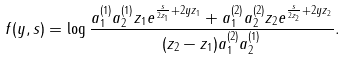<formula> <loc_0><loc_0><loc_500><loc_500>f ( y , s ) = \log \frac { a _ { 1 } ^ { ( 1 ) } a _ { 2 } ^ { ( 1 ) } z _ { 1 } e ^ { \frac { s } { 2 z _ { 1 } } + 2 y z _ { 1 } } + a _ { 1 } ^ { ( 2 ) } a _ { 2 } ^ { ( 2 ) } z _ { 2 } e ^ { \frac { s } { 2 z _ { 2 } } + 2 y z _ { 2 } } } { ( z _ { 2 } - z _ { 1 } ) a _ { 1 } ^ { ( 2 ) } a _ { 2 } ^ { ( 1 ) } } .</formula> 